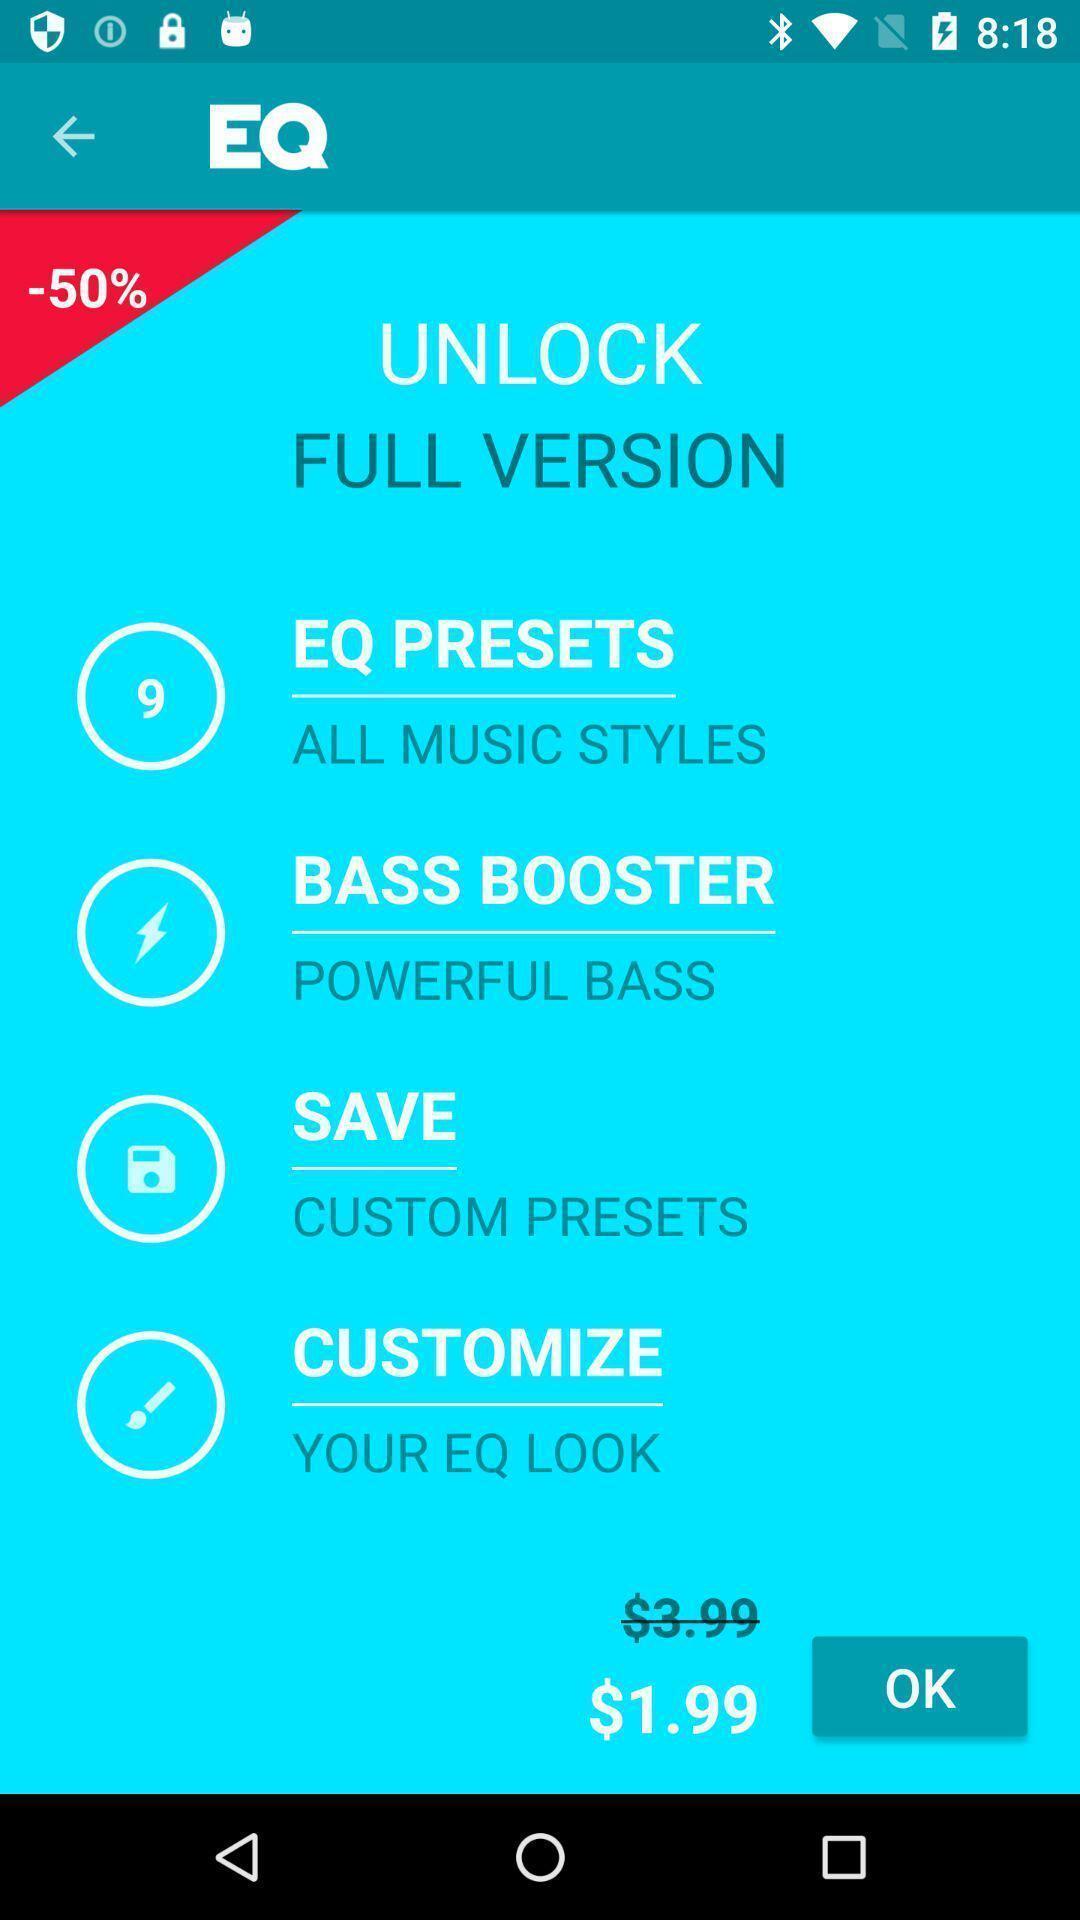Provide a description of this screenshot. Page of a music app with various options and price. 